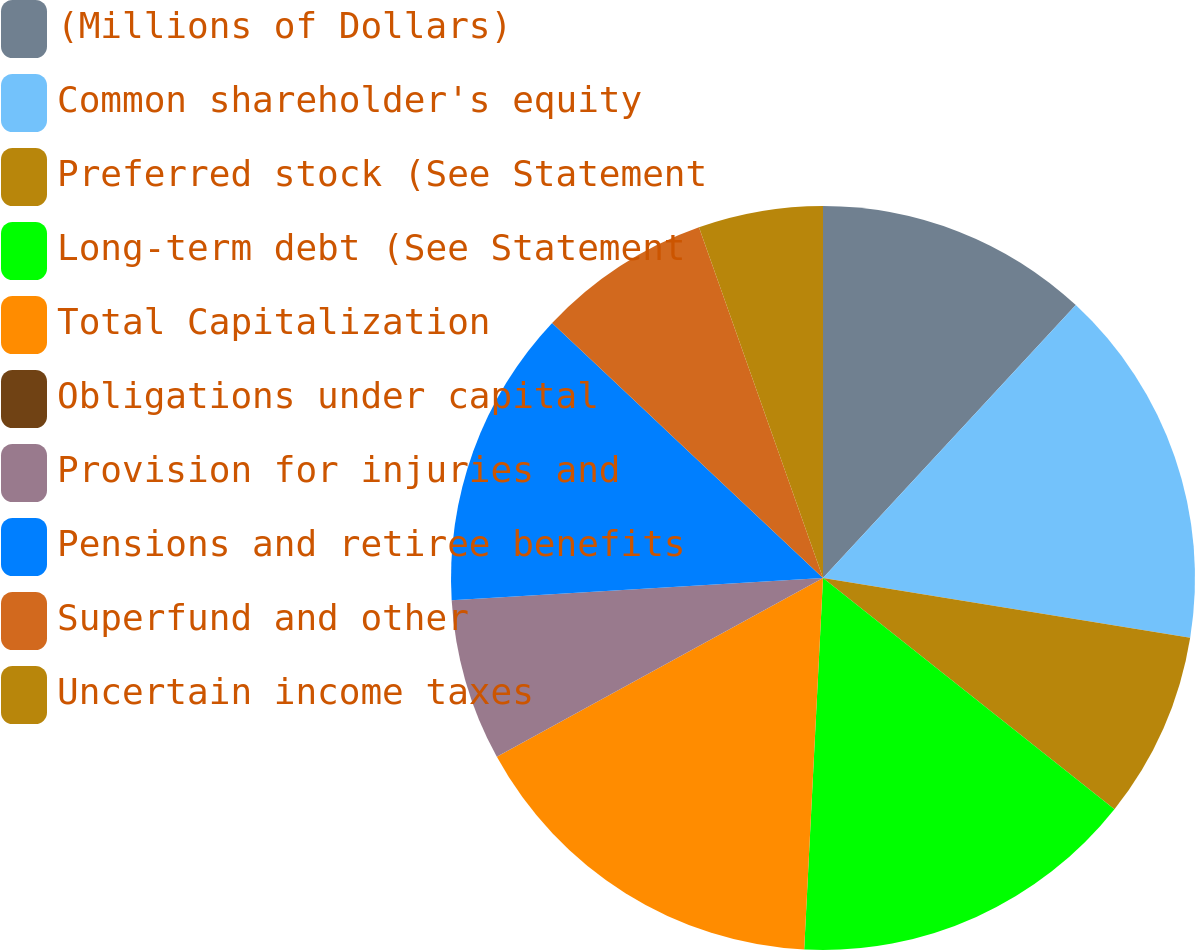<chart> <loc_0><loc_0><loc_500><loc_500><pie_chart><fcel>(Millions of Dollars)<fcel>Common shareholder's equity<fcel>Preferred stock (See Statement<fcel>Long-term debt (See Statement<fcel>Total Capitalization<fcel>Obligations under capital<fcel>Provision for injuries and<fcel>Pensions and retiree benefits<fcel>Superfund and other<fcel>Uncertain income taxes<nl><fcel>11.89%<fcel>15.67%<fcel>8.11%<fcel>15.13%<fcel>16.21%<fcel>0.0%<fcel>7.03%<fcel>12.97%<fcel>7.57%<fcel>5.41%<nl></chart> 